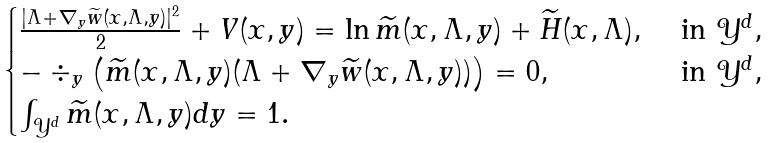<formula> <loc_0><loc_0><loc_500><loc_500>\begin{cases} \frac { | \Lambda + \nabla _ { y } \widetilde { w } ( x , \Lambda , y ) | ^ { 2 } } { 2 } + V ( x , y ) = \ln \widetilde { m } ( x , \Lambda , y ) + \widetilde { H } ( x , \Lambda ) , \ & \text {in} \ \mathcal { Y } ^ { d } , \\ - \div _ { y } \left ( \widetilde { m } ( x , \Lambda , y ) ( \Lambda + \nabla _ { y } \widetilde { w } ( x , \Lambda , y ) ) \right ) = 0 , \ & \text {in} \ \mathcal { Y } ^ { d } , \\ \int _ { \mathcal { Y } ^ { d } } \widetilde { m } ( x , \Lambda , y ) d y = 1 . \end{cases}</formula> 